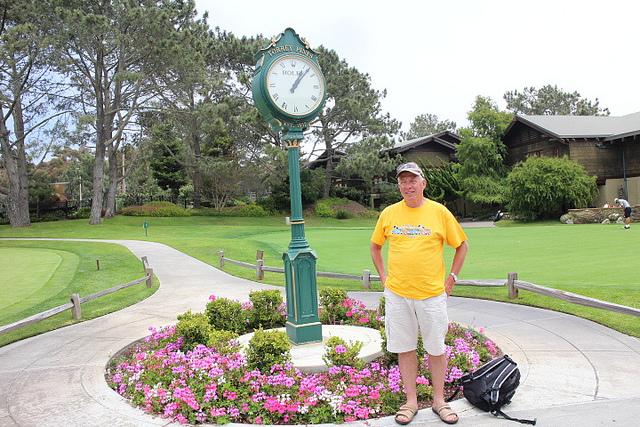Are the grounds well tended?
Concise answer only. Yes. What color are his shorts?
Give a very brief answer. White. What color is the man's shirt?
Be succinct. Yellow. 